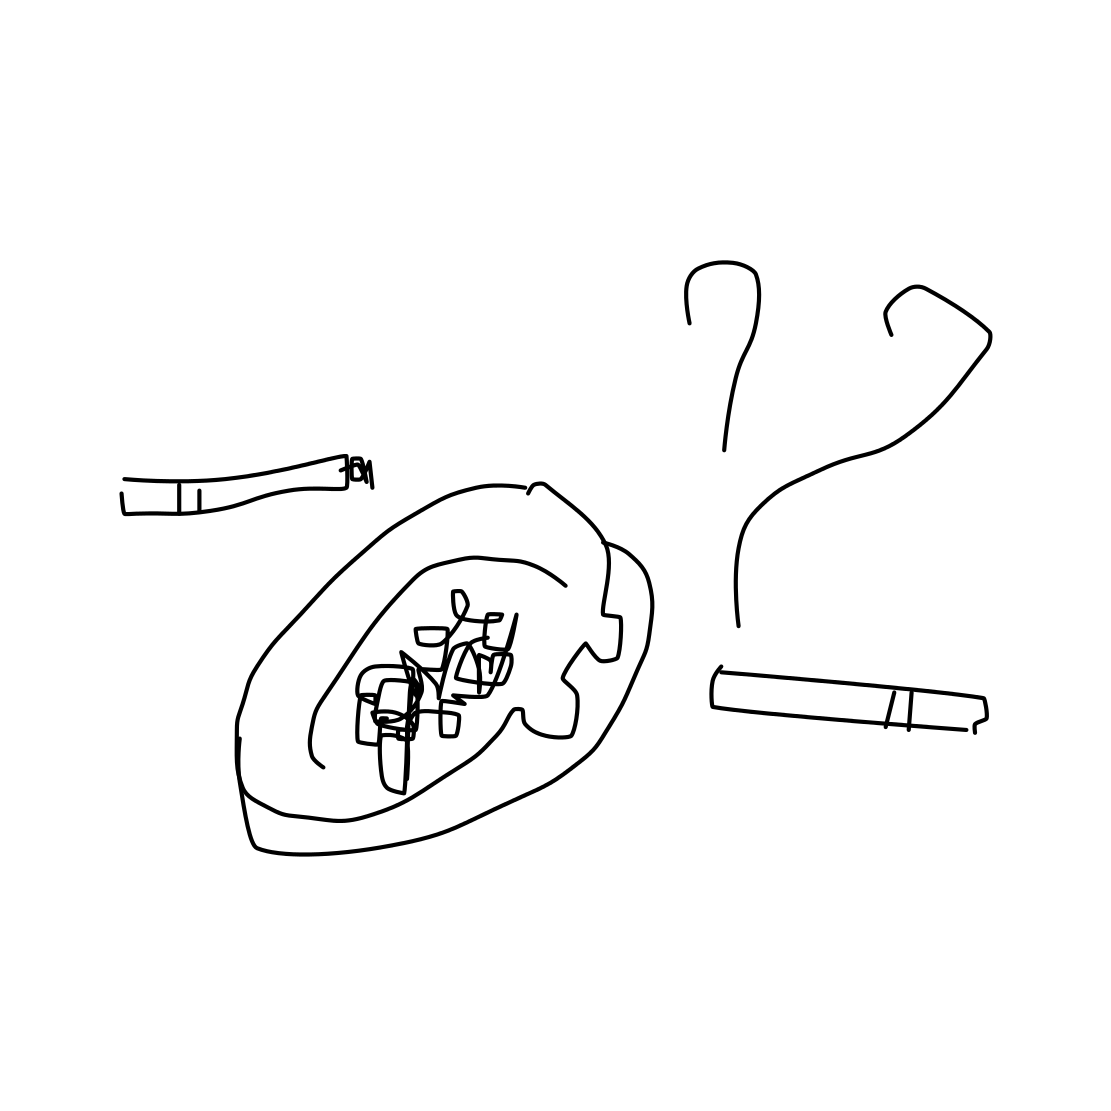In the scene, is an ashtray in it? Yes, the image prominently features an ashtray in the center, complete with butts that indicate it has been used. 